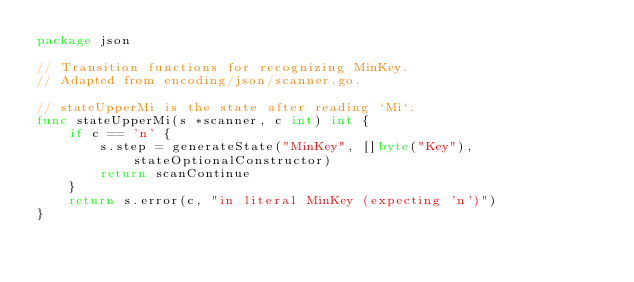Convert code to text. <code><loc_0><loc_0><loc_500><loc_500><_Go_>package json

// Transition functions for recognizing MinKey.
// Adapted from encoding/json/scanner.go.

// stateUpperMi is the state after reading `Mi`.
func stateUpperMi(s *scanner, c int) int {
	if c == 'n' {
		s.step = generateState("MinKey", []byte("Key"), stateOptionalConstructor)
		return scanContinue
	}
	return s.error(c, "in literal MinKey (expecting 'n')")
}
</code> 